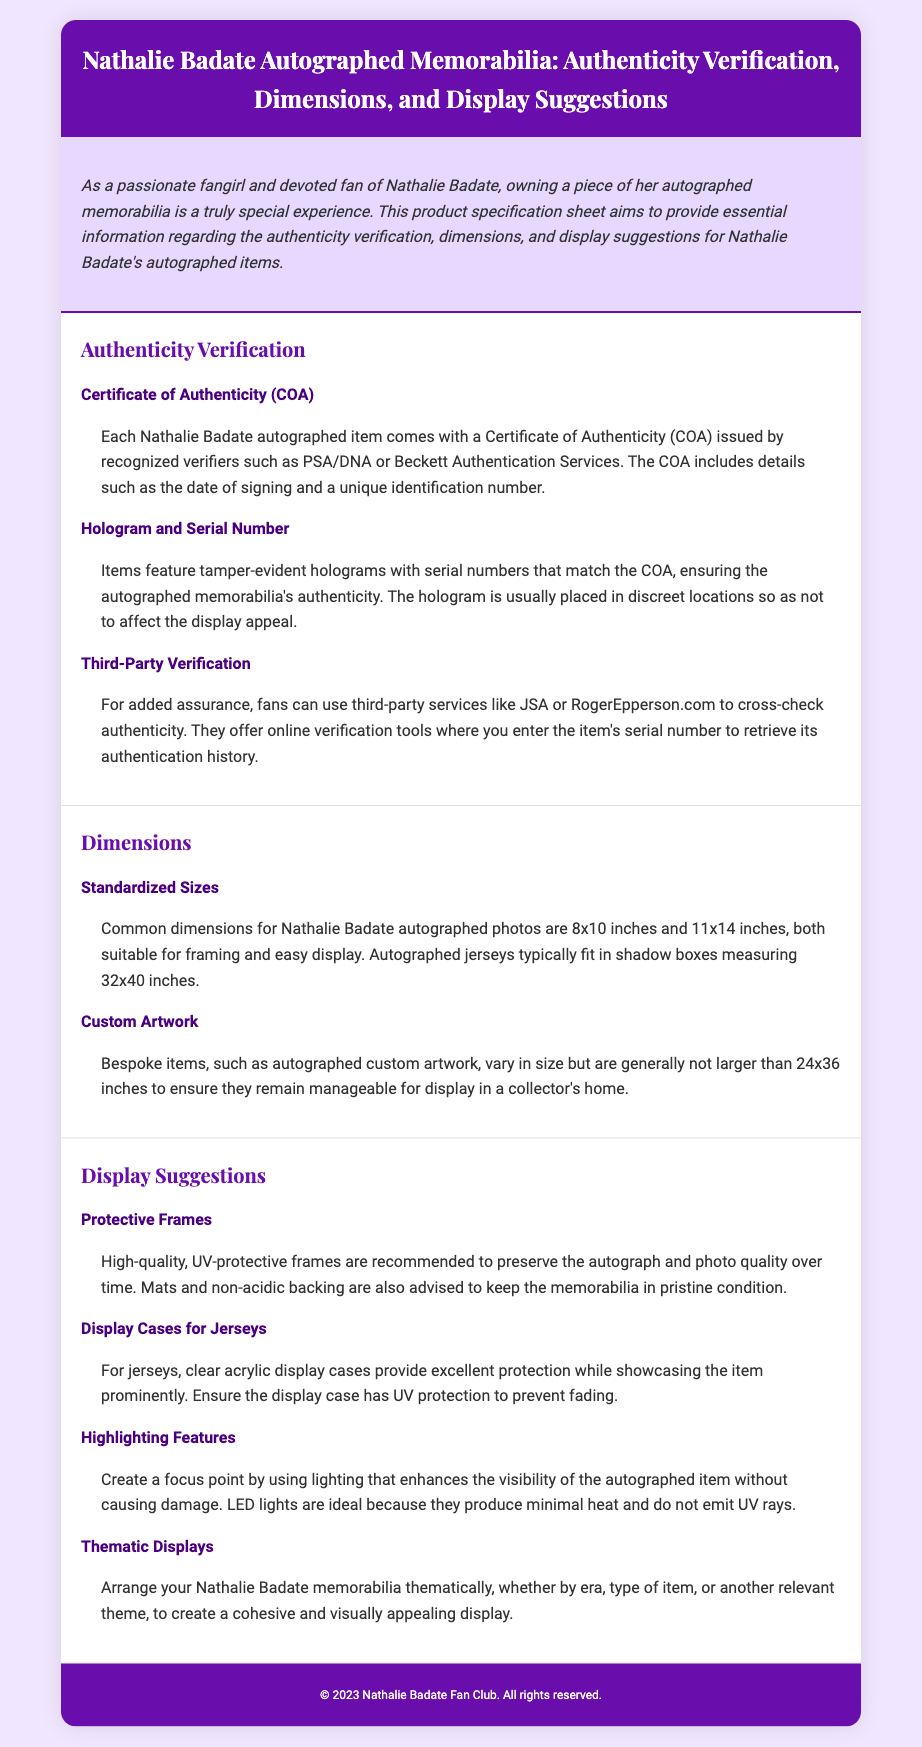what is included with each autographed item? The document states that each autographed item comes with a Certificate of Authenticity (COA) issued by recognized verifiers.
Answer: Certificate of Authenticity (COA) what are the common dimensions for autographed photos? The common dimensions for Nathalie Badate autographed photos are mentioned as 8x10 inches and 11x14 inches.
Answer: 8x10 inches and 11x14 inches which services can fans use for third-party verification? The document lists third-party services such as JSA and RogerEpperson.com for cross-checking authenticity.
Answer: JSA and RogerEpperson.com what is the maximum size for bespoke autographed items? The maximum size for bespoke autographed items is specified to be generally not larger than 24x36 inches.
Answer: 24x36 inches what type of lighting is recommended for displaying memorabilia? The document recommends using LED lights for enhancing the visibility of the autographed item.
Answer: LED lights how should jerseys be displayed? Clear acrylic display cases are recommended for providing protection while showcasing the jersey prominently.
Answer: Clear acrylic display cases how can fans preserve the autograph's quality? High-quality, UV-protective frames are recommended to preserve the autograph and photo quality over time.
Answer: High-quality, UV-protective frames what should be used for jersey display cases to prevent fading? The document mentions that display cases should have UV protection to prevent fading.
Answer: UV protection how can collections be organized for display? The document suggests arranging memorabilia thematically to create a cohesive and visually appealing display.
Answer: Thematically 